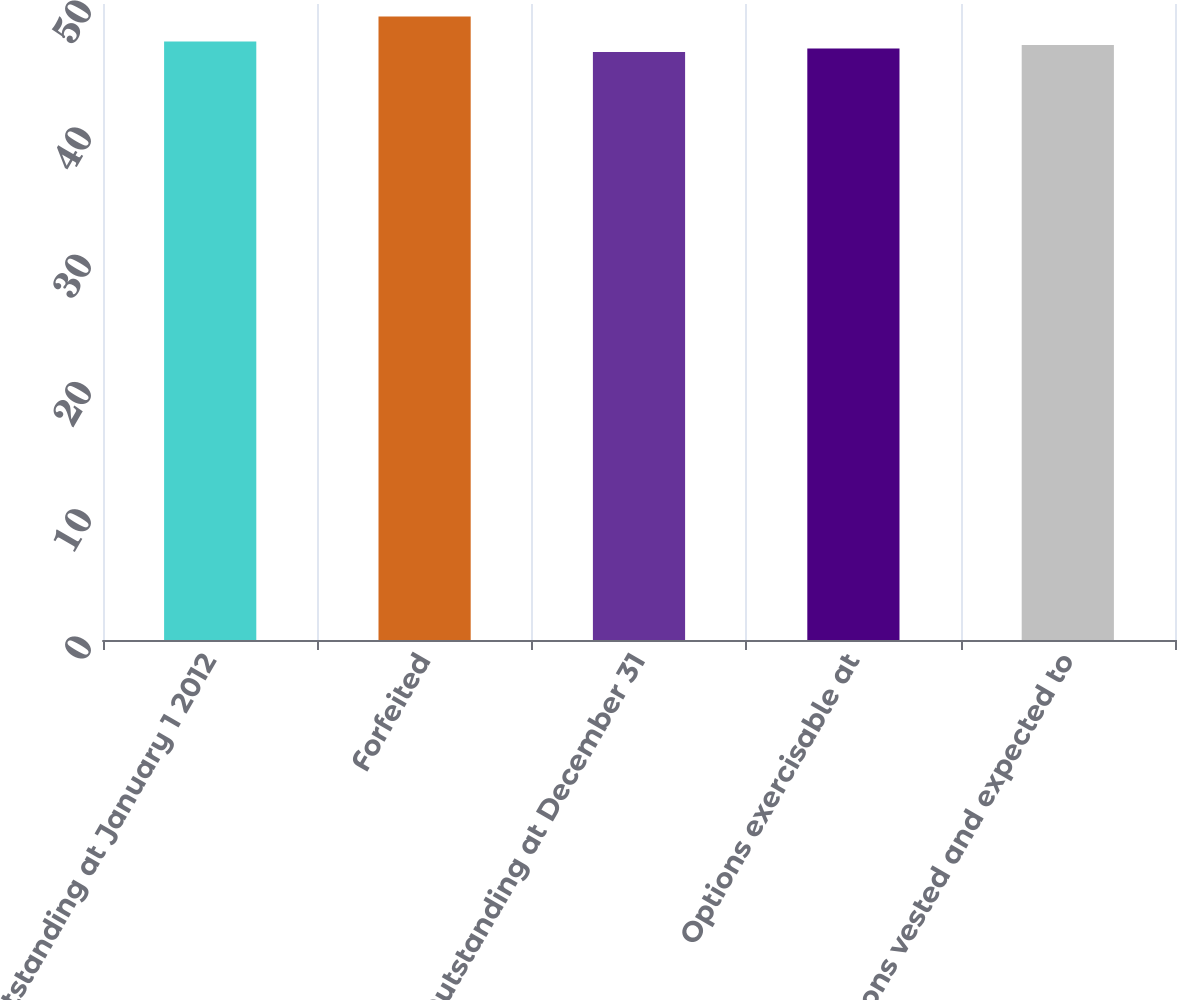<chart> <loc_0><loc_0><loc_500><loc_500><bar_chart><fcel>Outstanding at January 1 2012<fcel>Forfeited<fcel>Outstanding at December 31<fcel>Options exercisable at<fcel>Options vested and expected to<nl><fcel>47.06<fcel>49.02<fcel>46.22<fcel>46.5<fcel>46.78<nl></chart> 